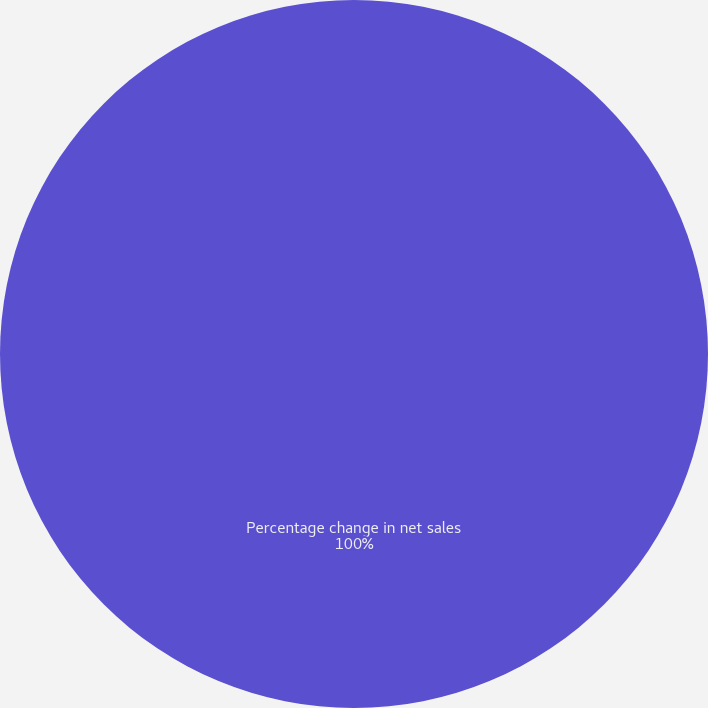<chart> <loc_0><loc_0><loc_500><loc_500><pie_chart><fcel>Percentage change in net sales<nl><fcel>100.0%<nl></chart> 